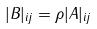Convert formula to latex. <formula><loc_0><loc_0><loc_500><loc_500>| B | _ { i j } = \rho | A | _ { i j }</formula> 